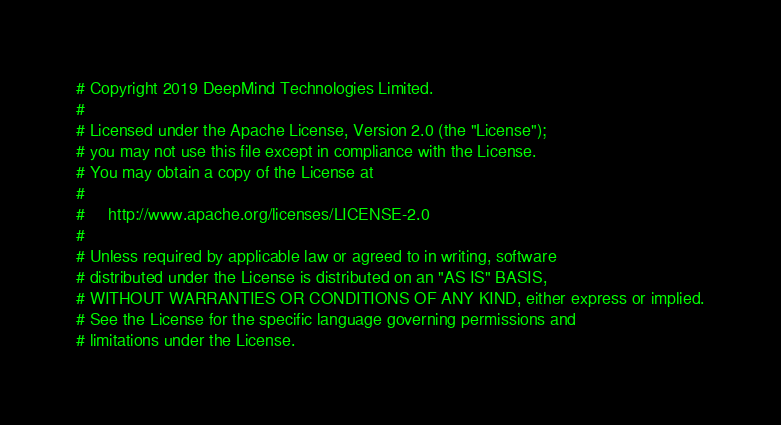Convert code to text. <code><loc_0><loc_0><loc_500><loc_500><_Python_># Copyright 2019 DeepMind Technologies Limited.
#
# Licensed under the Apache License, Version 2.0 (the "License");
# you may not use this file except in compliance with the License.
# You may obtain a copy of the License at
#
#     http://www.apache.org/licenses/LICENSE-2.0
#
# Unless required by applicable law or agreed to in writing, software
# distributed under the License is distributed on an "AS IS" BASIS,
# WITHOUT WARRANTIES OR CONDITIONS OF ANY KIND, either express or implied.
# See the License for the specific language governing permissions and
# limitations under the License.


</code> 